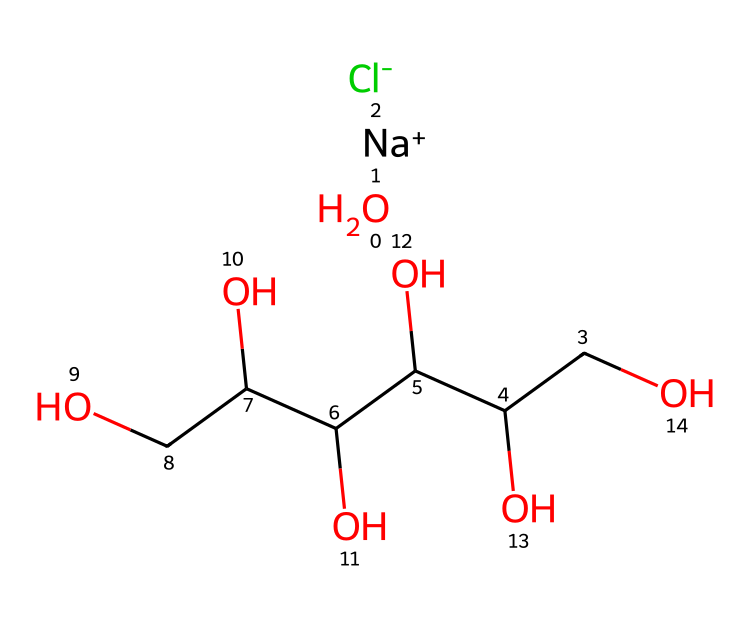What is the dominant cation in this compound? In the provided SMILES, the cation represented by [Na+] indicates that sodium is present and is the positively charged ion, which is typically the dominant cation in oral rehydration solutions.
Answer: sodium How many hydroxyl (OH) groups are present in the structure? Upon examining the SMILES, each 'O' connected to a carbon typically represents a hydroxyl group, and there are 5 'O's represented in the main structure connected to carbon atoms.
Answer: five Which ions contribute to the electrolyte properties of this compound? The presence of the sodium ion [Na+] and the chloride ion [Cl-] indicates that these are the ions responsible for the electrolyte properties since they can dissociate in solution and conduct electricity.
Answer: sodium and chloride What type of carbohydrate is represented in this solution? The presence of several carbon (C) atoms connected to multiple hydroxyl (OH) groups, arranged in a branched fashion, signifies that this compound contains a sugar alcohol, like glucose or a related structure that is high in hydroxyl groups.
Answer: sugar alcohol What is the overall electrical charge of the molecule in solution? In the SMILES, the +1 charge from the sodium ion and the -1 charge from the chloride ion cancel each other out, leading to an overall neutral charge for the molecule when dissolved in solution.
Answer: neutral 